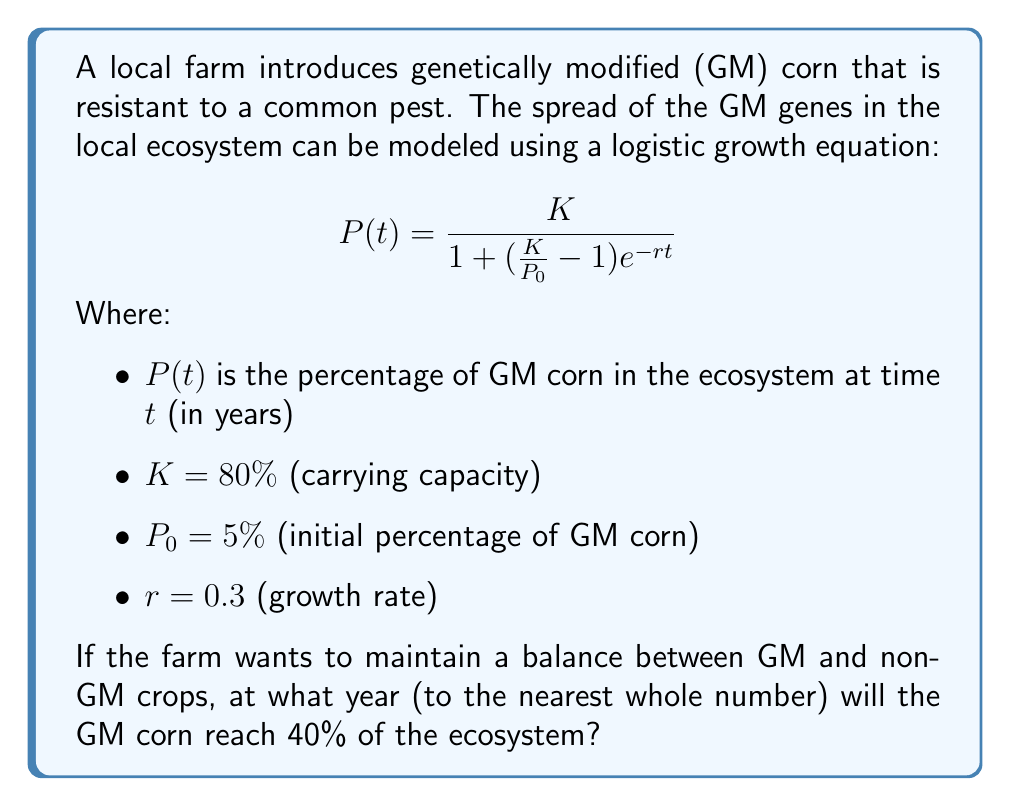What is the answer to this math problem? To solve this problem, we need to use the given logistic growth equation and solve for $t$ when $P(t) = 40\%$. Let's approach this step-by-step:

1) We start with the logistic growth equation:
   $$P(t) = \frac{K}{1 + (\frac{K}{P_0} - 1)e^{-rt}}$$

2) We know the following values:
   $K = 80\%$, $P_0 = 5\%$, $r = 0.3$, and we want to find $t$ when $P(t) = 40\%$

3) Let's substitute these values into the equation:
   $$40 = \frac{80}{1 + (\frac{80}{5} - 1)e^{-0.3t}}$$

4) Simplify the fraction inside the parentheses:
   $$40 = \frac{80}{1 + (16 - 1)e^{-0.3t}}$$
   $$40 = \frac{80}{1 + 15e^{-0.3t}}$$

5) Multiply both sides by the denominator:
   $$40(1 + 15e^{-0.3t}) = 80$$
   $$40 + 600e^{-0.3t} = 80$$

6) Subtract 40 from both sides:
   $$600e^{-0.3t} = 40$$

7) Divide both sides by 600:
   $$e^{-0.3t} = \frac{1}{15}$$

8) Take the natural log of both sides:
   $$-0.3t = \ln(\frac{1}{15})$$

9) Divide both sides by -0.3:
   $$t = -\frac{\ln(\frac{1}{15})}{0.3}$$

10) Calculate the result:
    $$t \approx 9.0265$$

11) Round to the nearest whole number:
    $$t \approx 9 \text{ years}$$

Therefore, the GM corn will reach 40% of the ecosystem after approximately 9 years.
Answer: 9 years 